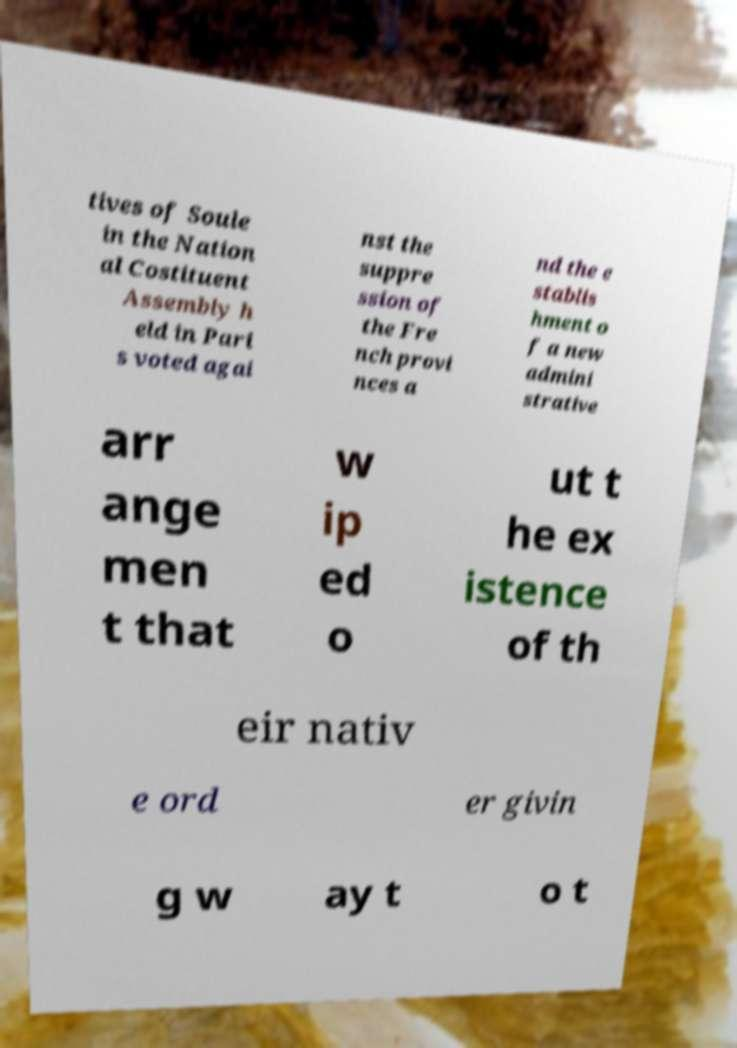Please identify and transcribe the text found in this image. tives of Soule in the Nation al Costituent Assembly h eld in Pari s voted agai nst the suppre ssion of the Fre nch provi nces a nd the e stablis hment o f a new admini strative arr ange men t that w ip ed o ut t he ex istence of th eir nativ e ord er givin g w ay t o t 